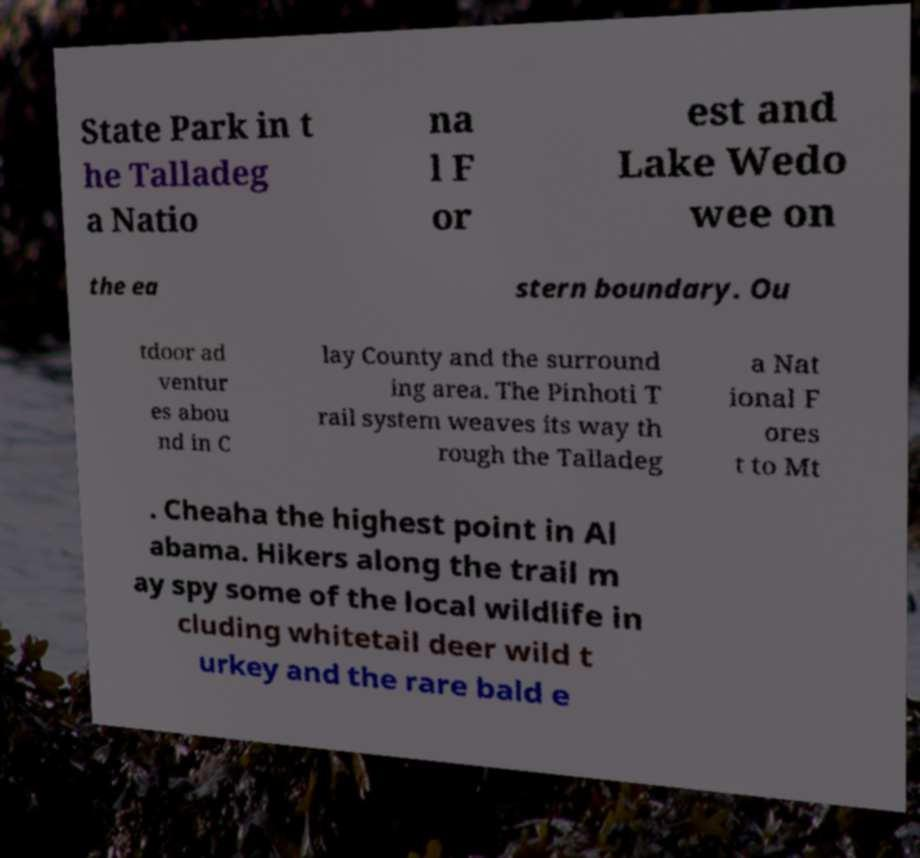Could you extract and type out the text from this image? State Park in t he Talladeg a Natio na l F or est and Lake Wedo wee on the ea stern boundary. Ou tdoor ad ventur es abou nd in C lay County and the surround ing area. The Pinhoti T rail system weaves its way th rough the Talladeg a Nat ional F ores t to Mt . Cheaha the highest point in Al abama. Hikers along the trail m ay spy some of the local wildlife in cluding whitetail deer wild t urkey and the rare bald e 